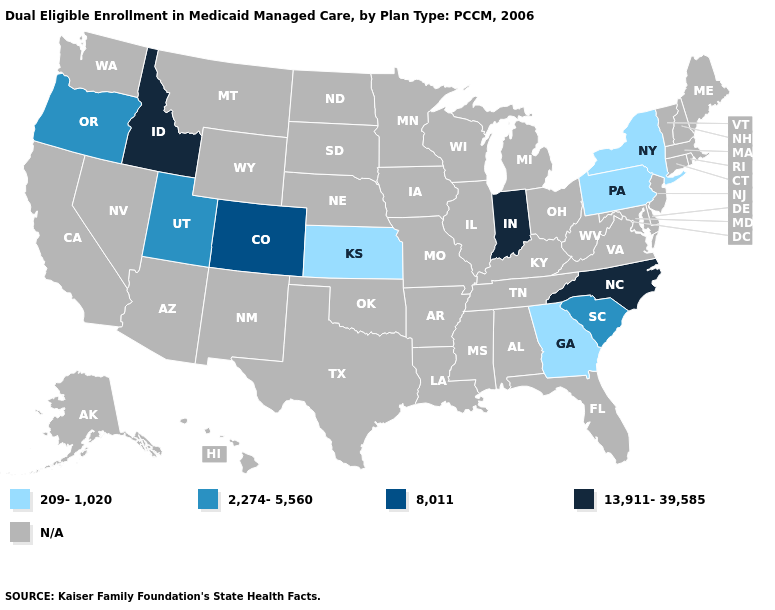What is the lowest value in the USA?
Give a very brief answer. 209-1,020. Name the states that have a value in the range 13,911-39,585?
Short answer required. Idaho, Indiana, North Carolina. What is the highest value in the West ?
Write a very short answer. 13,911-39,585. Which states have the highest value in the USA?
Give a very brief answer. Idaho, Indiana, North Carolina. What is the highest value in the MidWest ?
Concise answer only. 13,911-39,585. Name the states that have a value in the range 2,274-5,560?
Quick response, please. Oregon, South Carolina, Utah. Among the states that border Tennessee , which have the highest value?
Be succinct. North Carolina. What is the value of Nevada?
Keep it brief. N/A. What is the value of New York?
Concise answer only. 209-1,020. Which states have the lowest value in the South?
Give a very brief answer. Georgia. What is the lowest value in states that border Virginia?
Quick response, please. 13,911-39,585. Name the states that have a value in the range 2,274-5,560?
Quick response, please. Oregon, South Carolina, Utah. Does the map have missing data?
Quick response, please. Yes. What is the highest value in the West ?
Concise answer only. 13,911-39,585. 